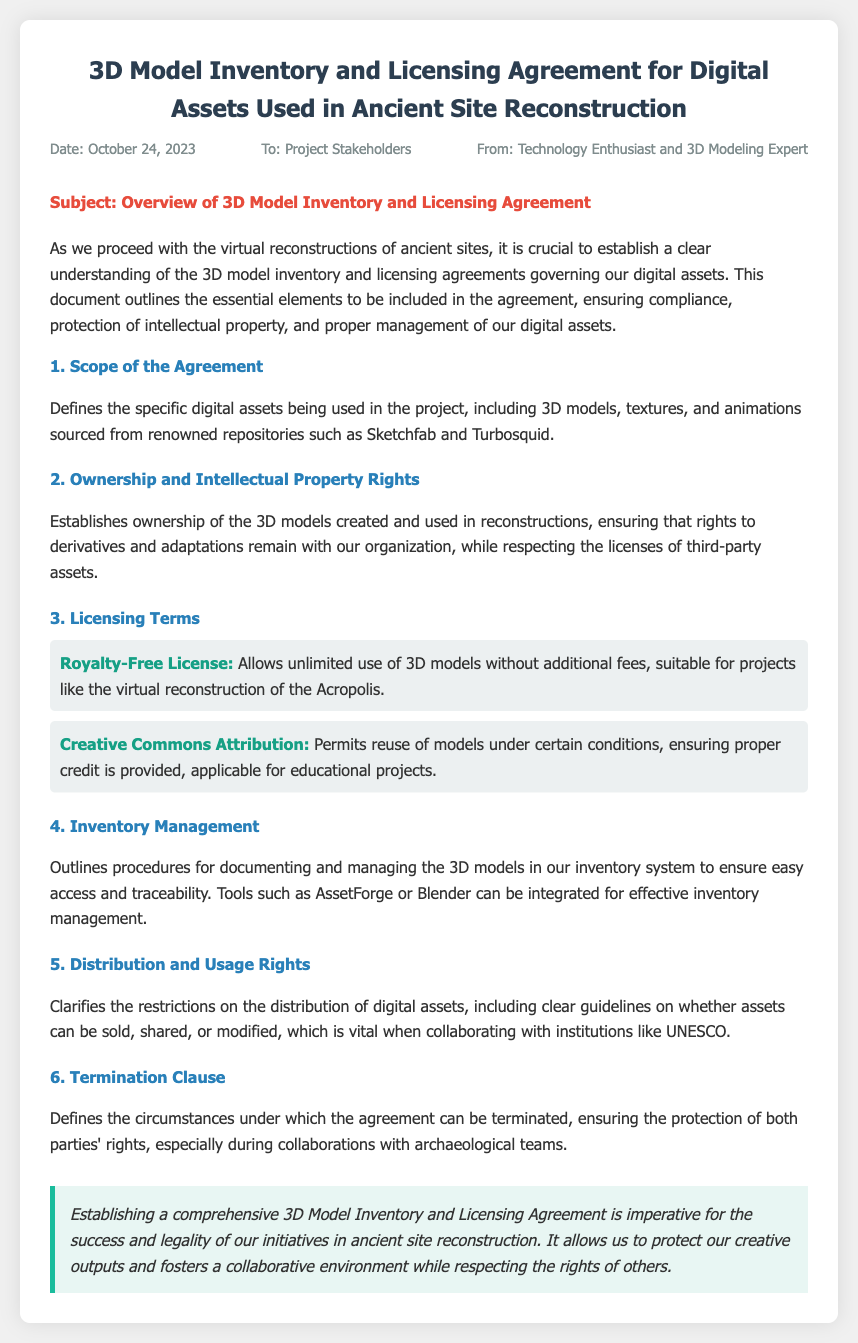What is the date of the memo? The date of the memo is mentioned at the top of the document.
Answer: October 24, 2023 Who is the memo addressed to? The recipient of the memo is specified in the document.
Answer: Project Stakeholders What type of license allows unlimited use of 3D models without additional fees? The licensing terms section outlines a specific type of license.
Answer: Royalty-Free License What are the tools suggested for inventory management? The document lists tools that can be integrated for effective inventory management.
Answer: AssetForge or Blender What section defines ownership of the 3D models? The ownership details are covered within a specific section of the memo.
Answer: Ownership and Intellectual Property Rights Which renowned repositories are mentioned for sourcing digital assets? The scope of the agreement specifies where to source the digital assets.
Answer: Sketchfab and Turbosquid What is required for the Creative Commons Attribution license? The document clarifies the conditions tied to a specific license type.
Answer: Proper credit is provided What clause defines circumstances for agreement termination? The memo includes a specific section discussing this aspect.
Answer: Termination Clause What is the main purpose of the memo? The introductory paragraph summarizes the overall intent of the document.
Answer: Overview of 3D Model Inventory and Licensing Agreement 